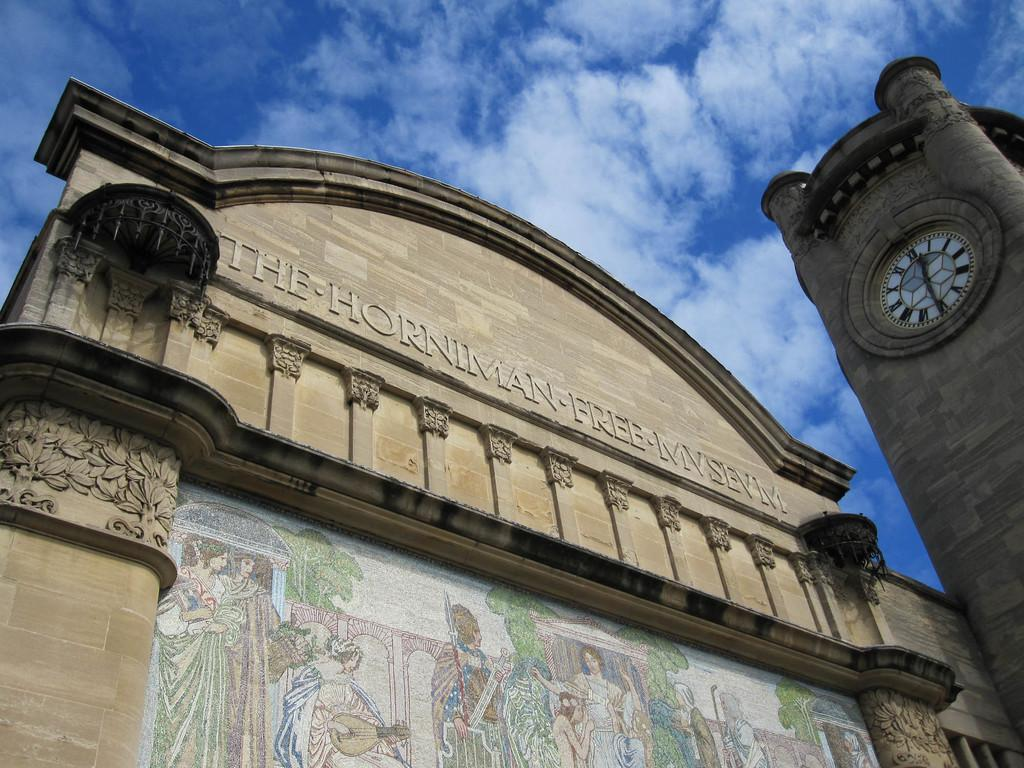What type of structure can be seen in the image? There is a building in the image. What decorative elements are present on the building? Paintings are present on the building. Can you describe another building in the image? There is a clock tower building in the image. What type of hammer is used to create the thrill in the image? There is no hammer or thrill present in the image; it features buildings with paintings and a clock tower. 